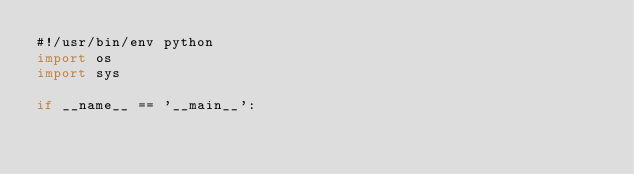<code> <loc_0><loc_0><loc_500><loc_500><_Python_>#!/usr/bin/env python
import os
import sys

if __name__ == '__main__':</code> 